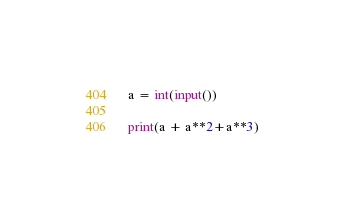<code> <loc_0><loc_0><loc_500><loc_500><_Python_>a = int(input())

print(a + a**2+a**3)</code> 